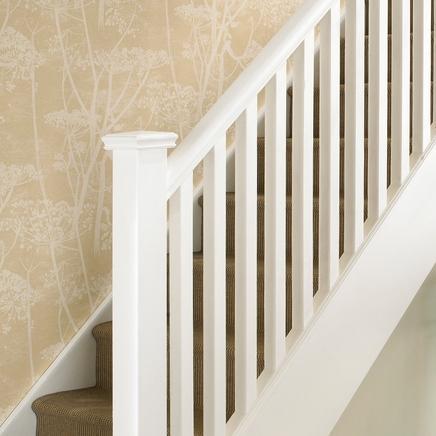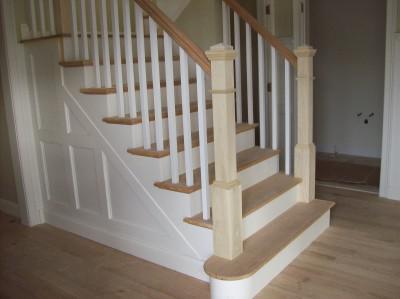The first image is the image on the left, the second image is the image on the right. For the images shown, is this caption "In at least one image there is a stair cause with dark colored trim and white rods." true? Answer yes or no. No. The first image is the image on the left, the second image is the image on the right. Evaluate the accuracy of this statement regarding the images: "Framed pictures line the stairway in one of the images.". Is it true? Answer yes or no. No. 